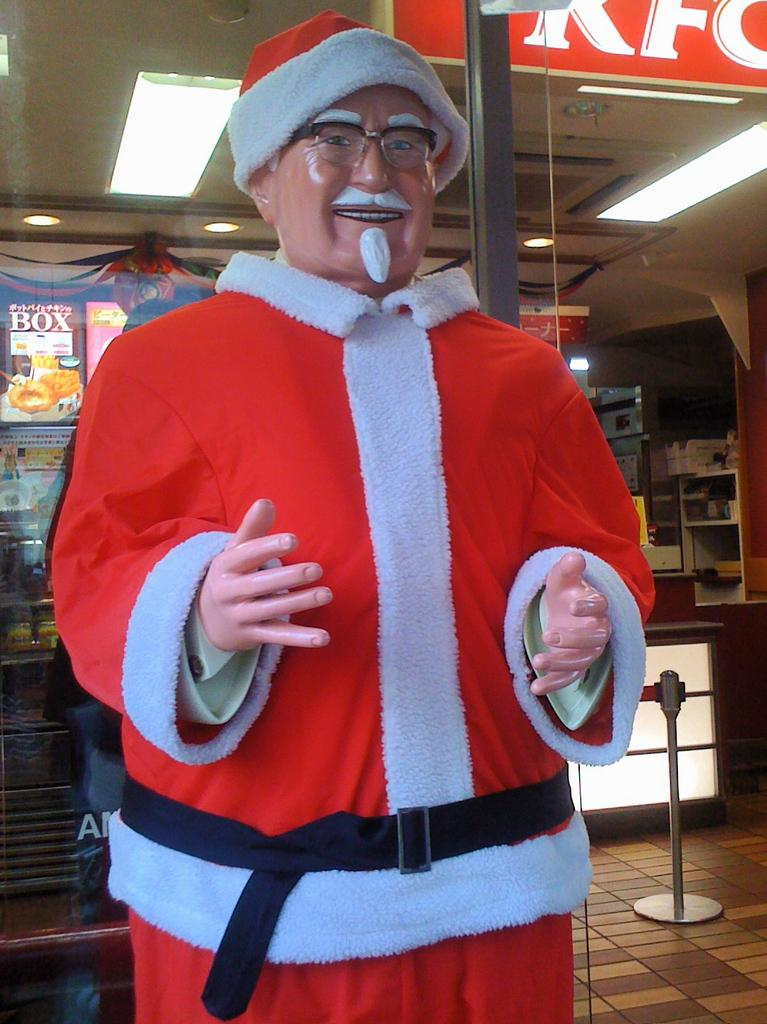What is the main subject of the image? There is a statue of Santa Claus in the image. What is the statue wearing? The Santa Claus statue is wearing a red and white dress, spectacles, and a cap. What can be seen in the background of the image? There is a store in the background of the image. What type of drain can be seen near the Santa Claus statue in the image? There is no drain visible in the image; it only features a statue of Santa Claus and a store in the background. 